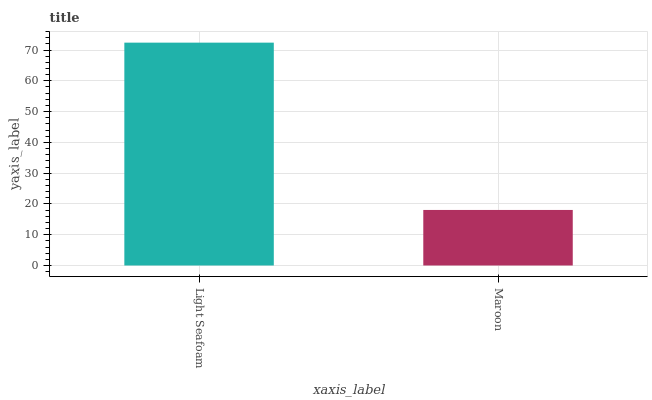Is Maroon the minimum?
Answer yes or no. Yes. Is Light Seafoam the maximum?
Answer yes or no. Yes. Is Maroon the maximum?
Answer yes or no. No. Is Light Seafoam greater than Maroon?
Answer yes or no. Yes. Is Maroon less than Light Seafoam?
Answer yes or no. Yes. Is Maroon greater than Light Seafoam?
Answer yes or no. No. Is Light Seafoam less than Maroon?
Answer yes or no. No. Is Light Seafoam the high median?
Answer yes or no. Yes. Is Maroon the low median?
Answer yes or no. Yes. Is Maroon the high median?
Answer yes or no. No. Is Light Seafoam the low median?
Answer yes or no. No. 